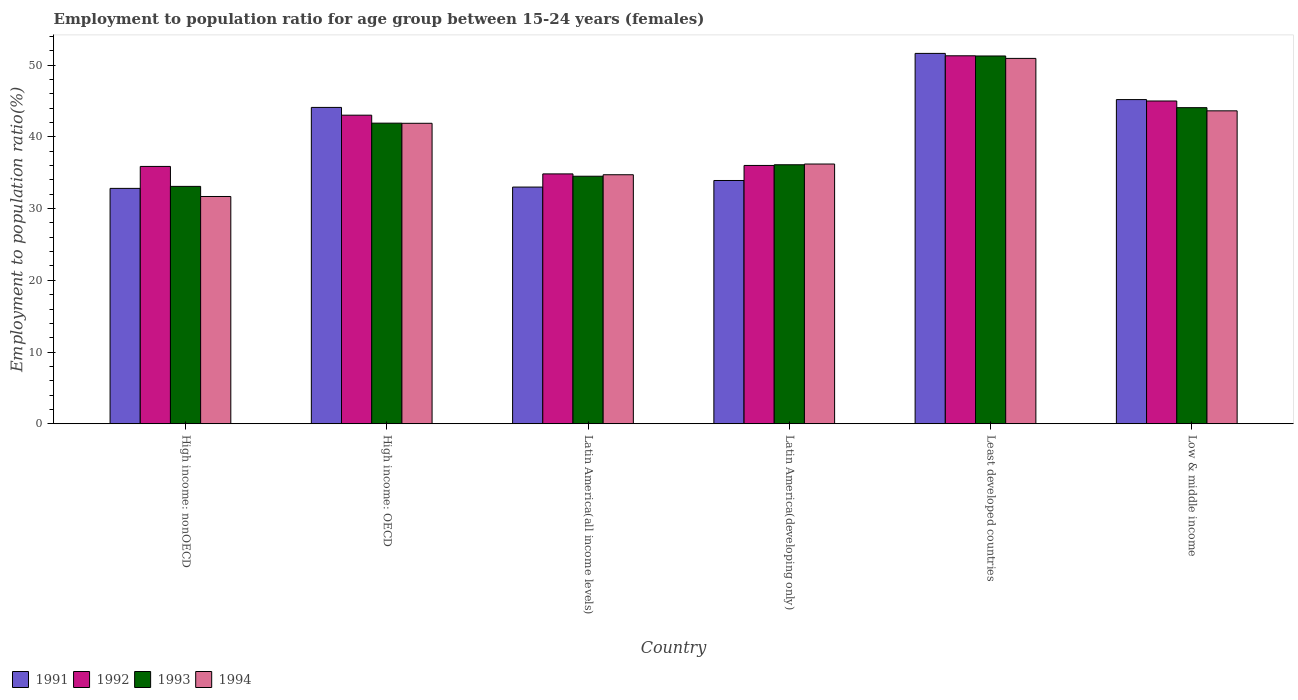How many groups of bars are there?
Make the answer very short. 6. Are the number of bars per tick equal to the number of legend labels?
Your answer should be compact. Yes. Are the number of bars on each tick of the X-axis equal?
Offer a very short reply. Yes. How many bars are there on the 6th tick from the right?
Offer a terse response. 4. What is the label of the 1st group of bars from the left?
Offer a terse response. High income: nonOECD. What is the employment to population ratio in 1992 in Least developed countries?
Your response must be concise. 51.32. Across all countries, what is the maximum employment to population ratio in 1994?
Your answer should be very brief. 50.95. Across all countries, what is the minimum employment to population ratio in 1992?
Offer a very short reply. 34.84. In which country was the employment to population ratio in 1992 maximum?
Your answer should be compact. Least developed countries. In which country was the employment to population ratio in 1993 minimum?
Your answer should be very brief. High income: nonOECD. What is the total employment to population ratio in 1991 in the graph?
Make the answer very short. 240.73. What is the difference between the employment to population ratio in 1994 in Latin America(all income levels) and that in Low & middle income?
Offer a very short reply. -8.91. What is the difference between the employment to population ratio in 1992 in High income: nonOECD and the employment to population ratio in 1994 in Latin America(all income levels)?
Provide a succinct answer. 1.16. What is the average employment to population ratio in 1994 per country?
Keep it short and to the point. 39.86. What is the difference between the employment to population ratio of/in 1991 and employment to population ratio of/in 1992 in Low & middle income?
Ensure brevity in your answer.  0.2. What is the ratio of the employment to population ratio in 1992 in Latin America(all income levels) to that in Low & middle income?
Keep it short and to the point. 0.77. What is the difference between the highest and the second highest employment to population ratio in 1991?
Your answer should be very brief. 7.53. What is the difference between the highest and the lowest employment to population ratio in 1991?
Ensure brevity in your answer.  18.83. In how many countries, is the employment to population ratio in 1991 greater than the average employment to population ratio in 1991 taken over all countries?
Provide a succinct answer. 3. Is the sum of the employment to population ratio in 1992 in High income: OECD and Latin America(developing only) greater than the maximum employment to population ratio in 1991 across all countries?
Provide a succinct answer. Yes. What is the difference between two consecutive major ticks on the Y-axis?
Your answer should be compact. 10. Are the values on the major ticks of Y-axis written in scientific E-notation?
Give a very brief answer. No. How many legend labels are there?
Provide a short and direct response. 4. What is the title of the graph?
Offer a terse response. Employment to population ratio for age group between 15-24 years (females). Does "2006" appear as one of the legend labels in the graph?
Provide a short and direct response. No. What is the Employment to population ratio(%) of 1991 in High income: nonOECD?
Your answer should be compact. 32.83. What is the Employment to population ratio(%) in 1992 in High income: nonOECD?
Your response must be concise. 35.89. What is the Employment to population ratio(%) in 1993 in High income: nonOECD?
Keep it short and to the point. 33.1. What is the Employment to population ratio(%) in 1994 in High income: nonOECD?
Your answer should be compact. 31.69. What is the Employment to population ratio(%) of 1991 in High income: OECD?
Your answer should be compact. 44.12. What is the Employment to population ratio(%) in 1992 in High income: OECD?
Offer a very short reply. 43.03. What is the Employment to population ratio(%) in 1993 in High income: OECD?
Provide a succinct answer. 41.92. What is the Employment to population ratio(%) in 1994 in High income: OECD?
Your answer should be very brief. 41.9. What is the Employment to population ratio(%) of 1991 in Latin America(all income levels)?
Your response must be concise. 33.01. What is the Employment to population ratio(%) in 1992 in Latin America(all income levels)?
Offer a very short reply. 34.84. What is the Employment to population ratio(%) in 1993 in Latin America(all income levels)?
Give a very brief answer. 34.52. What is the Employment to population ratio(%) in 1994 in Latin America(all income levels)?
Your answer should be very brief. 34.73. What is the Employment to population ratio(%) in 1991 in Latin America(developing only)?
Offer a terse response. 33.93. What is the Employment to population ratio(%) in 1992 in Latin America(developing only)?
Your answer should be compact. 36.02. What is the Employment to population ratio(%) of 1993 in Latin America(developing only)?
Offer a terse response. 36.12. What is the Employment to population ratio(%) of 1994 in Latin America(developing only)?
Provide a succinct answer. 36.22. What is the Employment to population ratio(%) in 1991 in Least developed countries?
Offer a very short reply. 51.65. What is the Employment to population ratio(%) in 1992 in Least developed countries?
Your answer should be very brief. 51.32. What is the Employment to population ratio(%) of 1993 in Least developed countries?
Your answer should be very brief. 51.29. What is the Employment to population ratio(%) of 1994 in Least developed countries?
Provide a short and direct response. 50.95. What is the Employment to population ratio(%) in 1991 in Low & middle income?
Provide a succinct answer. 45.21. What is the Employment to population ratio(%) of 1992 in Low & middle income?
Ensure brevity in your answer.  45.01. What is the Employment to population ratio(%) of 1993 in Low & middle income?
Ensure brevity in your answer.  44.08. What is the Employment to population ratio(%) in 1994 in Low & middle income?
Ensure brevity in your answer.  43.64. Across all countries, what is the maximum Employment to population ratio(%) of 1991?
Your response must be concise. 51.65. Across all countries, what is the maximum Employment to population ratio(%) in 1992?
Provide a short and direct response. 51.32. Across all countries, what is the maximum Employment to population ratio(%) in 1993?
Your answer should be very brief. 51.29. Across all countries, what is the maximum Employment to population ratio(%) of 1994?
Give a very brief answer. 50.95. Across all countries, what is the minimum Employment to population ratio(%) in 1991?
Give a very brief answer. 32.83. Across all countries, what is the minimum Employment to population ratio(%) in 1992?
Ensure brevity in your answer.  34.84. Across all countries, what is the minimum Employment to population ratio(%) in 1993?
Provide a short and direct response. 33.1. Across all countries, what is the minimum Employment to population ratio(%) in 1994?
Ensure brevity in your answer.  31.69. What is the total Employment to population ratio(%) of 1991 in the graph?
Keep it short and to the point. 240.73. What is the total Employment to population ratio(%) of 1992 in the graph?
Ensure brevity in your answer.  246.12. What is the total Employment to population ratio(%) of 1993 in the graph?
Offer a very short reply. 241.03. What is the total Employment to population ratio(%) of 1994 in the graph?
Give a very brief answer. 239.14. What is the difference between the Employment to population ratio(%) of 1991 in High income: nonOECD and that in High income: OECD?
Your answer should be very brief. -11.29. What is the difference between the Employment to population ratio(%) in 1992 in High income: nonOECD and that in High income: OECD?
Keep it short and to the point. -7.15. What is the difference between the Employment to population ratio(%) of 1993 in High income: nonOECD and that in High income: OECD?
Keep it short and to the point. -8.82. What is the difference between the Employment to population ratio(%) in 1994 in High income: nonOECD and that in High income: OECD?
Your answer should be compact. -10.21. What is the difference between the Employment to population ratio(%) in 1991 in High income: nonOECD and that in Latin America(all income levels)?
Your answer should be compact. -0.18. What is the difference between the Employment to population ratio(%) of 1992 in High income: nonOECD and that in Latin America(all income levels)?
Offer a very short reply. 1.04. What is the difference between the Employment to population ratio(%) of 1993 in High income: nonOECD and that in Latin America(all income levels)?
Your answer should be compact. -1.42. What is the difference between the Employment to population ratio(%) in 1994 in High income: nonOECD and that in Latin America(all income levels)?
Your response must be concise. -3.03. What is the difference between the Employment to population ratio(%) in 1991 in High income: nonOECD and that in Latin America(developing only)?
Make the answer very short. -1.1. What is the difference between the Employment to population ratio(%) in 1992 in High income: nonOECD and that in Latin America(developing only)?
Keep it short and to the point. -0.14. What is the difference between the Employment to population ratio(%) in 1993 in High income: nonOECD and that in Latin America(developing only)?
Make the answer very short. -3.02. What is the difference between the Employment to population ratio(%) in 1994 in High income: nonOECD and that in Latin America(developing only)?
Keep it short and to the point. -4.53. What is the difference between the Employment to population ratio(%) of 1991 in High income: nonOECD and that in Least developed countries?
Give a very brief answer. -18.83. What is the difference between the Employment to population ratio(%) of 1992 in High income: nonOECD and that in Least developed countries?
Keep it short and to the point. -15.43. What is the difference between the Employment to population ratio(%) of 1993 in High income: nonOECD and that in Least developed countries?
Provide a short and direct response. -18.19. What is the difference between the Employment to population ratio(%) in 1994 in High income: nonOECD and that in Least developed countries?
Offer a very short reply. -19.26. What is the difference between the Employment to population ratio(%) of 1991 in High income: nonOECD and that in Low & middle income?
Ensure brevity in your answer.  -12.38. What is the difference between the Employment to population ratio(%) of 1992 in High income: nonOECD and that in Low & middle income?
Make the answer very short. -9.13. What is the difference between the Employment to population ratio(%) of 1993 in High income: nonOECD and that in Low & middle income?
Ensure brevity in your answer.  -10.98. What is the difference between the Employment to population ratio(%) of 1994 in High income: nonOECD and that in Low & middle income?
Keep it short and to the point. -11.95. What is the difference between the Employment to population ratio(%) in 1991 in High income: OECD and that in Latin America(all income levels)?
Offer a terse response. 11.11. What is the difference between the Employment to population ratio(%) in 1992 in High income: OECD and that in Latin America(all income levels)?
Ensure brevity in your answer.  8.19. What is the difference between the Employment to population ratio(%) of 1993 in High income: OECD and that in Latin America(all income levels)?
Your answer should be compact. 7.4. What is the difference between the Employment to population ratio(%) of 1994 in High income: OECD and that in Latin America(all income levels)?
Provide a short and direct response. 7.18. What is the difference between the Employment to population ratio(%) of 1991 in High income: OECD and that in Latin America(developing only)?
Offer a terse response. 10.19. What is the difference between the Employment to population ratio(%) in 1992 in High income: OECD and that in Latin America(developing only)?
Offer a terse response. 7.01. What is the difference between the Employment to population ratio(%) of 1993 in High income: OECD and that in Latin America(developing only)?
Offer a very short reply. 5.8. What is the difference between the Employment to population ratio(%) in 1994 in High income: OECD and that in Latin America(developing only)?
Your answer should be compact. 5.68. What is the difference between the Employment to population ratio(%) of 1991 in High income: OECD and that in Least developed countries?
Offer a very short reply. -7.53. What is the difference between the Employment to population ratio(%) in 1992 in High income: OECD and that in Least developed countries?
Offer a terse response. -8.28. What is the difference between the Employment to population ratio(%) of 1993 in High income: OECD and that in Least developed countries?
Offer a very short reply. -9.37. What is the difference between the Employment to population ratio(%) of 1994 in High income: OECD and that in Least developed countries?
Offer a very short reply. -9.05. What is the difference between the Employment to population ratio(%) of 1991 in High income: OECD and that in Low & middle income?
Give a very brief answer. -1.09. What is the difference between the Employment to population ratio(%) of 1992 in High income: OECD and that in Low & middle income?
Offer a terse response. -1.98. What is the difference between the Employment to population ratio(%) in 1993 in High income: OECD and that in Low & middle income?
Keep it short and to the point. -2.16. What is the difference between the Employment to population ratio(%) of 1994 in High income: OECD and that in Low & middle income?
Offer a terse response. -1.74. What is the difference between the Employment to population ratio(%) in 1991 in Latin America(all income levels) and that in Latin America(developing only)?
Keep it short and to the point. -0.92. What is the difference between the Employment to population ratio(%) in 1992 in Latin America(all income levels) and that in Latin America(developing only)?
Ensure brevity in your answer.  -1.18. What is the difference between the Employment to population ratio(%) in 1993 in Latin America(all income levels) and that in Latin America(developing only)?
Provide a short and direct response. -1.6. What is the difference between the Employment to population ratio(%) in 1994 in Latin America(all income levels) and that in Latin America(developing only)?
Provide a succinct answer. -1.49. What is the difference between the Employment to population ratio(%) in 1991 in Latin America(all income levels) and that in Least developed countries?
Provide a succinct answer. -18.64. What is the difference between the Employment to population ratio(%) of 1992 in Latin America(all income levels) and that in Least developed countries?
Make the answer very short. -16.47. What is the difference between the Employment to population ratio(%) in 1993 in Latin America(all income levels) and that in Least developed countries?
Offer a terse response. -16.77. What is the difference between the Employment to population ratio(%) of 1994 in Latin America(all income levels) and that in Least developed countries?
Offer a very short reply. -16.23. What is the difference between the Employment to population ratio(%) in 1991 in Latin America(all income levels) and that in Low & middle income?
Your answer should be very brief. -12.2. What is the difference between the Employment to population ratio(%) of 1992 in Latin America(all income levels) and that in Low & middle income?
Provide a succinct answer. -10.17. What is the difference between the Employment to population ratio(%) in 1993 in Latin America(all income levels) and that in Low & middle income?
Offer a terse response. -9.56. What is the difference between the Employment to population ratio(%) in 1994 in Latin America(all income levels) and that in Low & middle income?
Offer a very short reply. -8.91. What is the difference between the Employment to population ratio(%) in 1991 in Latin America(developing only) and that in Least developed countries?
Give a very brief answer. -17.73. What is the difference between the Employment to population ratio(%) of 1992 in Latin America(developing only) and that in Least developed countries?
Ensure brevity in your answer.  -15.29. What is the difference between the Employment to population ratio(%) in 1993 in Latin America(developing only) and that in Least developed countries?
Your answer should be compact. -15.17. What is the difference between the Employment to population ratio(%) of 1994 in Latin America(developing only) and that in Least developed countries?
Provide a short and direct response. -14.73. What is the difference between the Employment to population ratio(%) in 1991 in Latin America(developing only) and that in Low & middle income?
Offer a terse response. -11.28. What is the difference between the Employment to population ratio(%) of 1992 in Latin America(developing only) and that in Low & middle income?
Your answer should be very brief. -8.99. What is the difference between the Employment to population ratio(%) of 1993 in Latin America(developing only) and that in Low & middle income?
Your answer should be very brief. -7.96. What is the difference between the Employment to population ratio(%) in 1994 in Latin America(developing only) and that in Low & middle income?
Make the answer very short. -7.42. What is the difference between the Employment to population ratio(%) in 1991 in Least developed countries and that in Low & middle income?
Offer a very short reply. 6.44. What is the difference between the Employment to population ratio(%) of 1992 in Least developed countries and that in Low & middle income?
Provide a succinct answer. 6.3. What is the difference between the Employment to population ratio(%) in 1993 in Least developed countries and that in Low & middle income?
Your answer should be compact. 7.21. What is the difference between the Employment to population ratio(%) of 1994 in Least developed countries and that in Low & middle income?
Make the answer very short. 7.31. What is the difference between the Employment to population ratio(%) of 1991 in High income: nonOECD and the Employment to population ratio(%) of 1992 in High income: OECD?
Provide a short and direct response. -10.21. What is the difference between the Employment to population ratio(%) in 1991 in High income: nonOECD and the Employment to population ratio(%) in 1993 in High income: OECD?
Make the answer very short. -9.1. What is the difference between the Employment to population ratio(%) in 1991 in High income: nonOECD and the Employment to population ratio(%) in 1994 in High income: OECD?
Offer a terse response. -9.08. What is the difference between the Employment to population ratio(%) in 1992 in High income: nonOECD and the Employment to population ratio(%) in 1993 in High income: OECD?
Give a very brief answer. -6.04. What is the difference between the Employment to population ratio(%) of 1992 in High income: nonOECD and the Employment to population ratio(%) of 1994 in High income: OECD?
Your answer should be compact. -6.02. What is the difference between the Employment to population ratio(%) of 1993 in High income: nonOECD and the Employment to population ratio(%) of 1994 in High income: OECD?
Keep it short and to the point. -8.8. What is the difference between the Employment to population ratio(%) of 1991 in High income: nonOECD and the Employment to population ratio(%) of 1992 in Latin America(all income levels)?
Keep it short and to the point. -2.02. What is the difference between the Employment to population ratio(%) of 1991 in High income: nonOECD and the Employment to population ratio(%) of 1993 in Latin America(all income levels)?
Offer a very short reply. -1.69. What is the difference between the Employment to population ratio(%) in 1991 in High income: nonOECD and the Employment to population ratio(%) in 1994 in Latin America(all income levels)?
Provide a short and direct response. -1.9. What is the difference between the Employment to population ratio(%) of 1992 in High income: nonOECD and the Employment to population ratio(%) of 1993 in Latin America(all income levels)?
Keep it short and to the point. 1.37. What is the difference between the Employment to population ratio(%) in 1992 in High income: nonOECD and the Employment to population ratio(%) in 1994 in Latin America(all income levels)?
Your answer should be compact. 1.16. What is the difference between the Employment to population ratio(%) in 1993 in High income: nonOECD and the Employment to population ratio(%) in 1994 in Latin America(all income levels)?
Make the answer very short. -1.62. What is the difference between the Employment to population ratio(%) in 1991 in High income: nonOECD and the Employment to population ratio(%) in 1992 in Latin America(developing only)?
Your response must be concise. -3.2. What is the difference between the Employment to population ratio(%) in 1991 in High income: nonOECD and the Employment to population ratio(%) in 1993 in Latin America(developing only)?
Your response must be concise. -3.29. What is the difference between the Employment to population ratio(%) of 1991 in High income: nonOECD and the Employment to population ratio(%) of 1994 in Latin America(developing only)?
Your response must be concise. -3.4. What is the difference between the Employment to population ratio(%) in 1992 in High income: nonOECD and the Employment to population ratio(%) in 1993 in Latin America(developing only)?
Your response must be concise. -0.23. What is the difference between the Employment to population ratio(%) of 1992 in High income: nonOECD and the Employment to population ratio(%) of 1994 in Latin America(developing only)?
Offer a terse response. -0.33. What is the difference between the Employment to population ratio(%) of 1993 in High income: nonOECD and the Employment to population ratio(%) of 1994 in Latin America(developing only)?
Your answer should be very brief. -3.12. What is the difference between the Employment to population ratio(%) of 1991 in High income: nonOECD and the Employment to population ratio(%) of 1992 in Least developed countries?
Offer a terse response. -18.49. What is the difference between the Employment to population ratio(%) in 1991 in High income: nonOECD and the Employment to population ratio(%) in 1993 in Least developed countries?
Make the answer very short. -18.47. What is the difference between the Employment to population ratio(%) of 1991 in High income: nonOECD and the Employment to population ratio(%) of 1994 in Least developed countries?
Provide a succinct answer. -18.13. What is the difference between the Employment to population ratio(%) in 1992 in High income: nonOECD and the Employment to population ratio(%) in 1993 in Least developed countries?
Make the answer very short. -15.4. What is the difference between the Employment to population ratio(%) in 1992 in High income: nonOECD and the Employment to population ratio(%) in 1994 in Least developed countries?
Give a very brief answer. -15.07. What is the difference between the Employment to population ratio(%) in 1993 in High income: nonOECD and the Employment to population ratio(%) in 1994 in Least developed countries?
Keep it short and to the point. -17.85. What is the difference between the Employment to population ratio(%) in 1991 in High income: nonOECD and the Employment to population ratio(%) in 1992 in Low & middle income?
Give a very brief answer. -12.19. What is the difference between the Employment to population ratio(%) in 1991 in High income: nonOECD and the Employment to population ratio(%) in 1993 in Low & middle income?
Keep it short and to the point. -11.26. What is the difference between the Employment to population ratio(%) of 1991 in High income: nonOECD and the Employment to population ratio(%) of 1994 in Low & middle income?
Offer a very short reply. -10.81. What is the difference between the Employment to population ratio(%) in 1992 in High income: nonOECD and the Employment to population ratio(%) in 1993 in Low & middle income?
Ensure brevity in your answer.  -8.2. What is the difference between the Employment to population ratio(%) of 1992 in High income: nonOECD and the Employment to population ratio(%) of 1994 in Low & middle income?
Offer a very short reply. -7.75. What is the difference between the Employment to population ratio(%) in 1993 in High income: nonOECD and the Employment to population ratio(%) in 1994 in Low & middle income?
Keep it short and to the point. -10.54. What is the difference between the Employment to population ratio(%) in 1991 in High income: OECD and the Employment to population ratio(%) in 1992 in Latin America(all income levels)?
Provide a succinct answer. 9.27. What is the difference between the Employment to population ratio(%) of 1991 in High income: OECD and the Employment to population ratio(%) of 1993 in Latin America(all income levels)?
Your response must be concise. 9.6. What is the difference between the Employment to population ratio(%) in 1991 in High income: OECD and the Employment to population ratio(%) in 1994 in Latin America(all income levels)?
Provide a short and direct response. 9.39. What is the difference between the Employment to population ratio(%) of 1992 in High income: OECD and the Employment to population ratio(%) of 1993 in Latin America(all income levels)?
Provide a short and direct response. 8.51. What is the difference between the Employment to population ratio(%) of 1992 in High income: OECD and the Employment to population ratio(%) of 1994 in Latin America(all income levels)?
Give a very brief answer. 8.31. What is the difference between the Employment to population ratio(%) of 1993 in High income: OECD and the Employment to population ratio(%) of 1994 in Latin America(all income levels)?
Provide a short and direct response. 7.2. What is the difference between the Employment to population ratio(%) in 1991 in High income: OECD and the Employment to population ratio(%) in 1992 in Latin America(developing only)?
Your response must be concise. 8.09. What is the difference between the Employment to population ratio(%) in 1991 in High income: OECD and the Employment to population ratio(%) in 1993 in Latin America(developing only)?
Offer a very short reply. 8. What is the difference between the Employment to population ratio(%) of 1991 in High income: OECD and the Employment to population ratio(%) of 1994 in Latin America(developing only)?
Ensure brevity in your answer.  7.9. What is the difference between the Employment to population ratio(%) of 1992 in High income: OECD and the Employment to population ratio(%) of 1993 in Latin America(developing only)?
Offer a very short reply. 6.91. What is the difference between the Employment to population ratio(%) in 1992 in High income: OECD and the Employment to population ratio(%) in 1994 in Latin America(developing only)?
Your answer should be compact. 6.81. What is the difference between the Employment to population ratio(%) in 1993 in High income: OECD and the Employment to population ratio(%) in 1994 in Latin America(developing only)?
Your response must be concise. 5.7. What is the difference between the Employment to population ratio(%) in 1991 in High income: OECD and the Employment to population ratio(%) in 1992 in Least developed countries?
Keep it short and to the point. -7.2. What is the difference between the Employment to population ratio(%) of 1991 in High income: OECD and the Employment to population ratio(%) of 1993 in Least developed countries?
Offer a terse response. -7.17. What is the difference between the Employment to population ratio(%) in 1991 in High income: OECD and the Employment to population ratio(%) in 1994 in Least developed countries?
Provide a succinct answer. -6.84. What is the difference between the Employment to population ratio(%) in 1992 in High income: OECD and the Employment to population ratio(%) in 1993 in Least developed countries?
Give a very brief answer. -8.26. What is the difference between the Employment to population ratio(%) of 1992 in High income: OECD and the Employment to population ratio(%) of 1994 in Least developed countries?
Your answer should be compact. -7.92. What is the difference between the Employment to population ratio(%) of 1993 in High income: OECD and the Employment to population ratio(%) of 1994 in Least developed countries?
Make the answer very short. -9.03. What is the difference between the Employment to population ratio(%) of 1991 in High income: OECD and the Employment to population ratio(%) of 1992 in Low & middle income?
Offer a very short reply. -0.9. What is the difference between the Employment to population ratio(%) in 1991 in High income: OECD and the Employment to population ratio(%) in 1993 in Low & middle income?
Provide a short and direct response. 0.04. What is the difference between the Employment to population ratio(%) of 1991 in High income: OECD and the Employment to population ratio(%) of 1994 in Low & middle income?
Offer a very short reply. 0.48. What is the difference between the Employment to population ratio(%) of 1992 in High income: OECD and the Employment to population ratio(%) of 1993 in Low & middle income?
Make the answer very short. -1.05. What is the difference between the Employment to population ratio(%) of 1992 in High income: OECD and the Employment to population ratio(%) of 1994 in Low & middle income?
Make the answer very short. -0.61. What is the difference between the Employment to population ratio(%) in 1993 in High income: OECD and the Employment to population ratio(%) in 1994 in Low & middle income?
Offer a very short reply. -1.72. What is the difference between the Employment to population ratio(%) in 1991 in Latin America(all income levels) and the Employment to population ratio(%) in 1992 in Latin America(developing only)?
Keep it short and to the point. -3.02. What is the difference between the Employment to population ratio(%) of 1991 in Latin America(all income levels) and the Employment to population ratio(%) of 1993 in Latin America(developing only)?
Offer a very short reply. -3.11. What is the difference between the Employment to population ratio(%) of 1991 in Latin America(all income levels) and the Employment to population ratio(%) of 1994 in Latin America(developing only)?
Keep it short and to the point. -3.21. What is the difference between the Employment to population ratio(%) in 1992 in Latin America(all income levels) and the Employment to population ratio(%) in 1993 in Latin America(developing only)?
Your response must be concise. -1.27. What is the difference between the Employment to population ratio(%) in 1992 in Latin America(all income levels) and the Employment to population ratio(%) in 1994 in Latin America(developing only)?
Make the answer very short. -1.38. What is the difference between the Employment to population ratio(%) in 1993 in Latin America(all income levels) and the Employment to population ratio(%) in 1994 in Latin America(developing only)?
Ensure brevity in your answer.  -1.7. What is the difference between the Employment to population ratio(%) of 1991 in Latin America(all income levels) and the Employment to population ratio(%) of 1992 in Least developed countries?
Offer a very short reply. -18.31. What is the difference between the Employment to population ratio(%) of 1991 in Latin America(all income levels) and the Employment to population ratio(%) of 1993 in Least developed countries?
Make the answer very short. -18.28. What is the difference between the Employment to population ratio(%) of 1991 in Latin America(all income levels) and the Employment to population ratio(%) of 1994 in Least developed countries?
Make the answer very short. -17.95. What is the difference between the Employment to population ratio(%) of 1992 in Latin America(all income levels) and the Employment to population ratio(%) of 1993 in Least developed countries?
Offer a very short reply. -16.45. What is the difference between the Employment to population ratio(%) of 1992 in Latin America(all income levels) and the Employment to population ratio(%) of 1994 in Least developed countries?
Ensure brevity in your answer.  -16.11. What is the difference between the Employment to population ratio(%) of 1993 in Latin America(all income levels) and the Employment to population ratio(%) of 1994 in Least developed countries?
Keep it short and to the point. -16.43. What is the difference between the Employment to population ratio(%) of 1991 in Latin America(all income levels) and the Employment to population ratio(%) of 1992 in Low & middle income?
Provide a succinct answer. -12.01. What is the difference between the Employment to population ratio(%) of 1991 in Latin America(all income levels) and the Employment to population ratio(%) of 1993 in Low & middle income?
Your response must be concise. -11.07. What is the difference between the Employment to population ratio(%) in 1991 in Latin America(all income levels) and the Employment to population ratio(%) in 1994 in Low & middle income?
Keep it short and to the point. -10.63. What is the difference between the Employment to population ratio(%) in 1992 in Latin America(all income levels) and the Employment to population ratio(%) in 1993 in Low & middle income?
Your response must be concise. -9.24. What is the difference between the Employment to population ratio(%) in 1992 in Latin America(all income levels) and the Employment to population ratio(%) in 1994 in Low & middle income?
Provide a short and direct response. -8.8. What is the difference between the Employment to population ratio(%) of 1993 in Latin America(all income levels) and the Employment to population ratio(%) of 1994 in Low & middle income?
Offer a very short reply. -9.12. What is the difference between the Employment to population ratio(%) in 1991 in Latin America(developing only) and the Employment to population ratio(%) in 1992 in Least developed countries?
Your answer should be very brief. -17.39. What is the difference between the Employment to population ratio(%) of 1991 in Latin America(developing only) and the Employment to population ratio(%) of 1993 in Least developed countries?
Offer a terse response. -17.37. What is the difference between the Employment to population ratio(%) in 1991 in Latin America(developing only) and the Employment to population ratio(%) in 1994 in Least developed countries?
Offer a terse response. -17.03. What is the difference between the Employment to population ratio(%) in 1992 in Latin America(developing only) and the Employment to population ratio(%) in 1993 in Least developed countries?
Offer a very short reply. -15.27. What is the difference between the Employment to population ratio(%) of 1992 in Latin America(developing only) and the Employment to population ratio(%) of 1994 in Least developed countries?
Provide a succinct answer. -14.93. What is the difference between the Employment to population ratio(%) in 1993 in Latin America(developing only) and the Employment to population ratio(%) in 1994 in Least developed countries?
Offer a very short reply. -14.84. What is the difference between the Employment to population ratio(%) of 1991 in Latin America(developing only) and the Employment to population ratio(%) of 1992 in Low & middle income?
Ensure brevity in your answer.  -11.09. What is the difference between the Employment to population ratio(%) in 1991 in Latin America(developing only) and the Employment to population ratio(%) in 1993 in Low & middle income?
Provide a succinct answer. -10.16. What is the difference between the Employment to population ratio(%) of 1991 in Latin America(developing only) and the Employment to population ratio(%) of 1994 in Low & middle income?
Your answer should be very brief. -9.71. What is the difference between the Employment to population ratio(%) of 1992 in Latin America(developing only) and the Employment to population ratio(%) of 1993 in Low & middle income?
Keep it short and to the point. -8.06. What is the difference between the Employment to population ratio(%) of 1992 in Latin America(developing only) and the Employment to population ratio(%) of 1994 in Low & middle income?
Provide a short and direct response. -7.62. What is the difference between the Employment to population ratio(%) in 1993 in Latin America(developing only) and the Employment to population ratio(%) in 1994 in Low & middle income?
Offer a very short reply. -7.52. What is the difference between the Employment to population ratio(%) in 1991 in Least developed countries and the Employment to population ratio(%) in 1992 in Low & middle income?
Offer a very short reply. 6.64. What is the difference between the Employment to population ratio(%) in 1991 in Least developed countries and the Employment to population ratio(%) in 1993 in Low & middle income?
Make the answer very short. 7.57. What is the difference between the Employment to population ratio(%) of 1991 in Least developed countries and the Employment to population ratio(%) of 1994 in Low & middle income?
Keep it short and to the point. 8.01. What is the difference between the Employment to population ratio(%) of 1992 in Least developed countries and the Employment to population ratio(%) of 1993 in Low & middle income?
Provide a short and direct response. 7.23. What is the difference between the Employment to population ratio(%) in 1992 in Least developed countries and the Employment to population ratio(%) in 1994 in Low & middle income?
Ensure brevity in your answer.  7.68. What is the difference between the Employment to population ratio(%) in 1993 in Least developed countries and the Employment to population ratio(%) in 1994 in Low & middle income?
Your response must be concise. 7.65. What is the average Employment to population ratio(%) in 1991 per country?
Offer a very short reply. 40.12. What is the average Employment to population ratio(%) in 1992 per country?
Your answer should be very brief. 41.02. What is the average Employment to population ratio(%) of 1993 per country?
Make the answer very short. 40.17. What is the average Employment to population ratio(%) in 1994 per country?
Keep it short and to the point. 39.86. What is the difference between the Employment to population ratio(%) in 1991 and Employment to population ratio(%) in 1992 in High income: nonOECD?
Your answer should be compact. -3.06. What is the difference between the Employment to population ratio(%) of 1991 and Employment to population ratio(%) of 1993 in High income: nonOECD?
Offer a very short reply. -0.28. What is the difference between the Employment to population ratio(%) of 1991 and Employment to population ratio(%) of 1994 in High income: nonOECD?
Make the answer very short. 1.13. What is the difference between the Employment to population ratio(%) of 1992 and Employment to population ratio(%) of 1993 in High income: nonOECD?
Offer a very short reply. 2.78. What is the difference between the Employment to population ratio(%) in 1992 and Employment to population ratio(%) in 1994 in High income: nonOECD?
Your response must be concise. 4.19. What is the difference between the Employment to population ratio(%) in 1993 and Employment to population ratio(%) in 1994 in High income: nonOECD?
Keep it short and to the point. 1.41. What is the difference between the Employment to population ratio(%) of 1991 and Employment to population ratio(%) of 1992 in High income: OECD?
Give a very brief answer. 1.08. What is the difference between the Employment to population ratio(%) in 1991 and Employment to population ratio(%) in 1993 in High income: OECD?
Give a very brief answer. 2.2. What is the difference between the Employment to population ratio(%) of 1991 and Employment to population ratio(%) of 1994 in High income: OECD?
Make the answer very short. 2.21. What is the difference between the Employment to population ratio(%) of 1992 and Employment to population ratio(%) of 1993 in High income: OECD?
Your response must be concise. 1.11. What is the difference between the Employment to population ratio(%) of 1992 and Employment to population ratio(%) of 1994 in High income: OECD?
Provide a succinct answer. 1.13. What is the difference between the Employment to population ratio(%) in 1993 and Employment to population ratio(%) in 1994 in High income: OECD?
Your response must be concise. 0.02. What is the difference between the Employment to population ratio(%) in 1991 and Employment to population ratio(%) in 1992 in Latin America(all income levels)?
Offer a terse response. -1.84. What is the difference between the Employment to population ratio(%) of 1991 and Employment to population ratio(%) of 1993 in Latin America(all income levels)?
Offer a very short reply. -1.51. What is the difference between the Employment to population ratio(%) of 1991 and Employment to population ratio(%) of 1994 in Latin America(all income levels)?
Offer a terse response. -1.72. What is the difference between the Employment to population ratio(%) in 1992 and Employment to population ratio(%) in 1993 in Latin America(all income levels)?
Provide a succinct answer. 0.32. What is the difference between the Employment to population ratio(%) of 1992 and Employment to population ratio(%) of 1994 in Latin America(all income levels)?
Make the answer very short. 0.12. What is the difference between the Employment to population ratio(%) in 1993 and Employment to population ratio(%) in 1994 in Latin America(all income levels)?
Offer a very short reply. -0.21. What is the difference between the Employment to population ratio(%) in 1991 and Employment to population ratio(%) in 1992 in Latin America(developing only)?
Provide a short and direct response. -2.1. What is the difference between the Employment to population ratio(%) in 1991 and Employment to population ratio(%) in 1993 in Latin America(developing only)?
Keep it short and to the point. -2.19. What is the difference between the Employment to population ratio(%) in 1991 and Employment to population ratio(%) in 1994 in Latin America(developing only)?
Provide a short and direct response. -2.3. What is the difference between the Employment to population ratio(%) in 1992 and Employment to population ratio(%) in 1993 in Latin America(developing only)?
Your answer should be very brief. -0.09. What is the difference between the Employment to population ratio(%) in 1992 and Employment to population ratio(%) in 1994 in Latin America(developing only)?
Your response must be concise. -0.2. What is the difference between the Employment to population ratio(%) of 1993 and Employment to population ratio(%) of 1994 in Latin America(developing only)?
Your answer should be very brief. -0.1. What is the difference between the Employment to population ratio(%) in 1991 and Employment to population ratio(%) in 1992 in Least developed countries?
Your answer should be very brief. 0.33. What is the difference between the Employment to population ratio(%) of 1991 and Employment to population ratio(%) of 1993 in Least developed countries?
Provide a succinct answer. 0.36. What is the difference between the Employment to population ratio(%) of 1991 and Employment to population ratio(%) of 1994 in Least developed countries?
Provide a short and direct response. 0.7. What is the difference between the Employment to population ratio(%) of 1992 and Employment to population ratio(%) of 1993 in Least developed countries?
Give a very brief answer. 0.03. What is the difference between the Employment to population ratio(%) in 1992 and Employment to population ratio(%) in 1994 in Least developed countries?
Your response must be concise. 0.36. What is the difference between the Employment to population ratio(%) in 1993 and Employment to population ratio(%) in 1994 in Least developed countries?
Make the answer very short. 0.34. What is the difference between the Employment to population ratio(%) of 1991 and Employment to population ratio(%) of 1992 in Low & middle income?
Give a very brief answer. 0.2. What is the difference between the Employment to population ratio(%) in 1991 and Employment to population ratio(%) in 1993 in Low & middle income?
Provide a succinct answer. 1.13. What is the difference between the Employment to population ratio(%) in 1991 and Employment to population ratio(%) in 1994 in Low & middle income?
Keep it short and to the point. 1.57. What is the difference between the Employment to population ratio(%) in 1992 and Employment to population ratio(%) in 1993 in Low & middle income?
Keep it short and to the point. 0.93. What is the difference between the Employment to population ratio(%) in 1992 and Employment to population ratio(%) in 1994 in Low & middle income?
Your answer should be compact. 1.37. What is the difference between the Employment to population ratio(%) in 1993 and Employment to population ratio(%) in 1994 in Low & middle income?
Your answer should be compact. 0.44. What is the ratio of the Employment to population ratio(%) in 1991 in High income: nonOECD to that in High income: OECD?
Offer a very short reply. 0.74. What is the ratio of the Employment to population ratio(%) in 1992 in High income: nonOECD to that in High income: OECD?
Offer a terse response. 0.83. What is the ratio of the Employment to population ratio(%) in 1993 in High income: nonOECD to that in High income: OECD?
Your answer should be compact. 0.79. What is the ratio of the Employment to population ratio(%) in 1994 in High income: nonOECD to that in High income: OECD?
Provide a succinct answer. 0.76. What is the ratio of the Employment to population ratio(%) of 1991 in High income: nonOECD to that in Latin America(all income levels)?
Your answer should be compact. 0.99. What is the ratio of the Employment to population ratio(%) of 1992 in High income: nonOECD to that in Latin America(all income levels)?
Provide a succinct answer. 1.03. What is the ratio of the Employment to population ratio(%) of 1994 in High income: nonOECD to that in Latin America(all income levels)?
Give a very brief answer. 0.91. What is the ratio of the Employment to population ratio(%) of 1991 in High income: nonOECD to that in Latin America(developing only)?
Keep it short and to the point. 0.97. What is the ratio of the Employment to population ratio(%) in 1993 in High income: nonOECD to that in Latin America(developing only)?
Offer a very short reply. 0.92. What is the ratio of the Employment to population ratio(%) in 1994 in High income: nonOECD to that in Latin America(developing only)?
Provide a succinct answer. 0.88. What is the ratio of the Employment to population ratio(%) of 1991 in High income: nonOECD to that in Least developed countries?
Your answer should be compact. 0.64. What is the ratio of the Employment to population ratio(%) of 1992 in High income: nonOECD to that in Least developed countries?
Your answer should be very brief. 0.7. What is the ratio of the Employment to population ratio(%) of 1993 in High income: nonOECD to that in Least developed countries?
Provide a short and direct response. 0.65. What is the ratio of the Employment to population ratio(%) in 1994 in High income: nonOECD to that in Least developed countries?
Your answer should be very brief. 0.62. What is the ratio of the Employment to population ratio(%) of 1991 in High income: nonOECD to that in Low & middle income?
Your response must be concise. 0.73. What is the ratio of the Employment to population ratio(%) of 1992 in High income: nonOECD to that in Low & middle income?
Make the answer very short. 0.8. What is the ratio of the Employment to population ratio(%) in 1993 in High income: nonOECD to that in Low & middle income?
Ensure brevity in your answer.  0.75. What is the ratio of the Employment to population ratio(%) of 1994 in High income: nonOECD to that in Low & middle income?
Provide a short and direct response. 0.73. What is the ratio of the Employment to population ratio(%) of 1991 in High income: OECD to that in Latin America(all income levels)?
Your answer should be very brief. 1.34. What is the ratio of the Employment to population ratio(%) of 1992 in High income: OECD to that in Latin America(all income levels)?
Provide a short and direct response. 1.24. What is the ratio of the Employment to population ratio(%) in 1993 in High income: OECD to that in Latin America(all income levels)?
Offer a very short reply. 1.21. What is the ratio of the Employment to population ratio(%) of 1994 in High income: OECD to that in Latin America(all income levels)?
Ensure brevity in your answer.  1.21. What is the ratio of the Employment to population ratio(%) of 1991 in High income: OECD to that in Latin America(developing only)?
Offer a terse response. 1.3. What is the ratio of the Employment to population ratio(%) of 1992 in High income: OECD to that in Latin America(developing only)?
Offer a very short reply. 1.19. What is the ratio of the Employment to population ratio(%) of 1993 in High income: OECD to that in Latin America(developing only)?
Provide a succinct answer. 1.16. What is the ratio of the Employment to population ratio(%) in 1994 in High income: OECD to that in Latin America(developing only)?
Provide a short and direct response. 1.16. What is the ratio of the Employment to population ratio(%) in 1991 in High income: OECD to that in Least developed countries?
Keep it short and to the point. 0.85. What is the ratio of the Employment to population ratio(%) of 1992 in High income: OECD to that in Least developed countries?
Make the answer very short. 0.84. What is the ratio of the Employment to population ratio(%) in 1993 in High income: OECD to that in Least developed countries?
Keep it short and to the point. 0.82. What is the ratio of the Employment to population ratio(%) in 1994 in High income: OECD to that in Least developed countries?
Your answer should be compact. 0.82. What is the ratio of the Employment to population ratio(%) in 1991 in High income: OECD to that in Low & middle income?
Offer a terse response. 0.98. What is the ratio of the Employment to population ratio(%) in 1992 in High income: OECD to that in Low & middle income?
Make the answer very short. 0.96. What is the ratio of the Employment to population ratio(%) in 1993 in High income: OECD to that in Low & middle income?
Offer a terse response. 0.95. What is the ratio of the Employment to population ratio(%) in 1994 in High income: OECD to that in Low & middle income?
Your response must be concise. 0.96. What is the ratio of the Employment to population ratio(%) of 1991 in Latin America(all income levels) to that in Latin America(developing only)?
Offer a very short reply. 0.97. What is the ratio of the Employment to population ratio(%) in 1992 in Latin America(all income levels) to that in Latin America(developing only)?
Offer a terse response. 0.97. What is the ratio of the Employment to population ratio(%) in 1993 in Latin America(all income levels) to that in Latin America(developing only)?
Offer a very short reply. 0.96. What is the ratio of the Employment to population ratio(%) of 1994 in Latin America(all income levels) to that in Latin America(developing only)?
Your answer should be very brief. 0.96. What is the ratio of the Employment to population ratio(%) of 1991 in Latin America(all income levels) to that in Least developed countries?
Make the answer very short. 0.64. What is the ratio of the Employment to population ratio(%) of 1992 in Latin America(all income levels) to that in Least developed countries?
Provide a succinct answer. 0.68. What is the ratio of the Employment to population ratio(%) of 1993 in Latin America(all income levels) to that in Least developed countries?
Offer a terse response. 0.67. What is the ratio of the Employment to population ratio(%) in 1994 in Latin America(all income levels) to that in Least developed countries?
Give a very brief answer. 0.68. What is the ratio of the Employment to population ratio(%) in 1991 in Latin America(all income levels) to that in Low & middle income?
Your response must be concise. 0.73. What is the ratio of the Employment to population ratio(%) in 1992 in Latin America(all income levels) to that in Low & middle income?
Offer a terse response. 0.77. What is the ratio of the Employment to population ratio(%) of 1993 in Latin America(all income levels) to that in Low & middle income?
Ensure brevity in your answer.  0.78. What is the ratio of the Employment to population ratio(%) in 1994 in Latin America(all income levels) to that in Low & middle income?
Provide a short and direct response. 0.8. What is the ratio of the Employment to population ratio(%) of 1991 in Latin America(developing only) to that in Least developed countries?
Your answer should be very brief. 0.66. What is the ratio of the Employment to population ratio(%) in 1992 in Latin America(developing only) to that in Least developed countries?
Provide a short and direct response. 0.7. What is the ratio of the Employment to population ratio(%) in 1993 in Latin America(developing only) to that in Least developed countries?
Make the answer very short. 0.7. What is the ratio of the Employment to population ratio(%) in 1994 in Latin America(developing only) to that in Least developed countries?
Give a very brief answer. 0.71. What is the ratio of the Employment to population ratio(%) of 1991 in Latin America(developing only) to that in Low & middle income?
Your response must be concise. 0.75. What is the ratio of the Employment to population ratio(%) of 1992 in Latin America(developing only) to that in Low & middle income?
Keep it short and to the point. 0.8. What is the ratio of the Employment to population ratio(%) in 1993 in Latin America(developing only) to that in Low & middle income?
Make the answer very short. 0.82. What is the ratio of the Employment to population ratio(%) of 1994 in Latin America(developing only) to that in Low & middle income?
Your response must be concise. 0.83. What is the ratio of the Employment to population ratio(%) of 1991 in Least developed countries to that in Low & middle income?
Ensure brevity in your answer.  1.14. What is the ratio of the Employment to population ratio(%) in 1992 in Least developed countries to that in Low & middle income?
Offer a very short reply. 1.14. What is the ratio of the Employment to population ratio(%) in 1993 in Least developed countries to that in Low & middle income?
Your answer should be very brief. 1.16. What is the ratio of the Employment to population ratio(%) in 1994 in Least developed countries to that in Low & middle income?
Ensure brevity in your answer.  1.17. What is the difference between the highest and the second highest Employment to population ratio(%) in 1991?
Make the answer very short. 6.44. What is the difference between the highest and the second highest Employment to population ratio(%) of 1992?
Provide a succinct answer. 6.3. What is the difference between the highest and the second highest Employment to population ratio(%) of 1993?
Your answer should be very brief. 7.21. What is the difference between the highest and the second highest Employment to population ratio(%) in 1994?
Give a very brief answer. 7.31. What is the difference between the highest and the lowest Employment to population ratio(%) in 1991?
Keep it short and to the point. 18.83. What is the difference between the highest and the lowest Employment to population ratio(%) in 1992?
Ensure brevity in your answer.  16.47. What is the difference between the highest and the lowest Employment to population ratio(%) in 1993?
Ensure brevity in your answer.  18.19. What is the difference between the highest and the lowest Employment to population ratio(%) in 1994?
Your answer should be very brief. 19.26. 